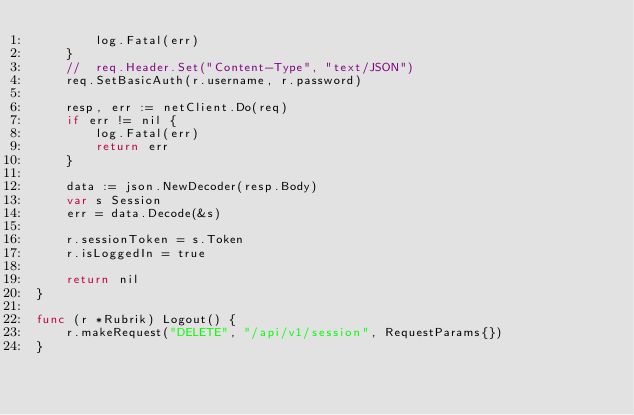<code> <loc_0><loc_0><loc_500><loc_500><_Go_>		log.Fatal(err)
	}
	//	req.Header.Set("Content-Type", "text/JSON")
	req.SetBasicAuth(r.username, r.password)

	resp, err := netClient.Do(req)
	if err != nil {
		log.Fatal(err)
		return err
	}

	data := json.NewDecoder(resp.Body)
	var s Session
	err = data.Decode(&s)

	r.sessionToken = s.Token
	r.isLoggedIn = true

	return nil
}

func (r *Rubrik) Logout() {
	r.makeRequest("DELETE", "/api/v1/session", RequestParams{})
}
</code> 